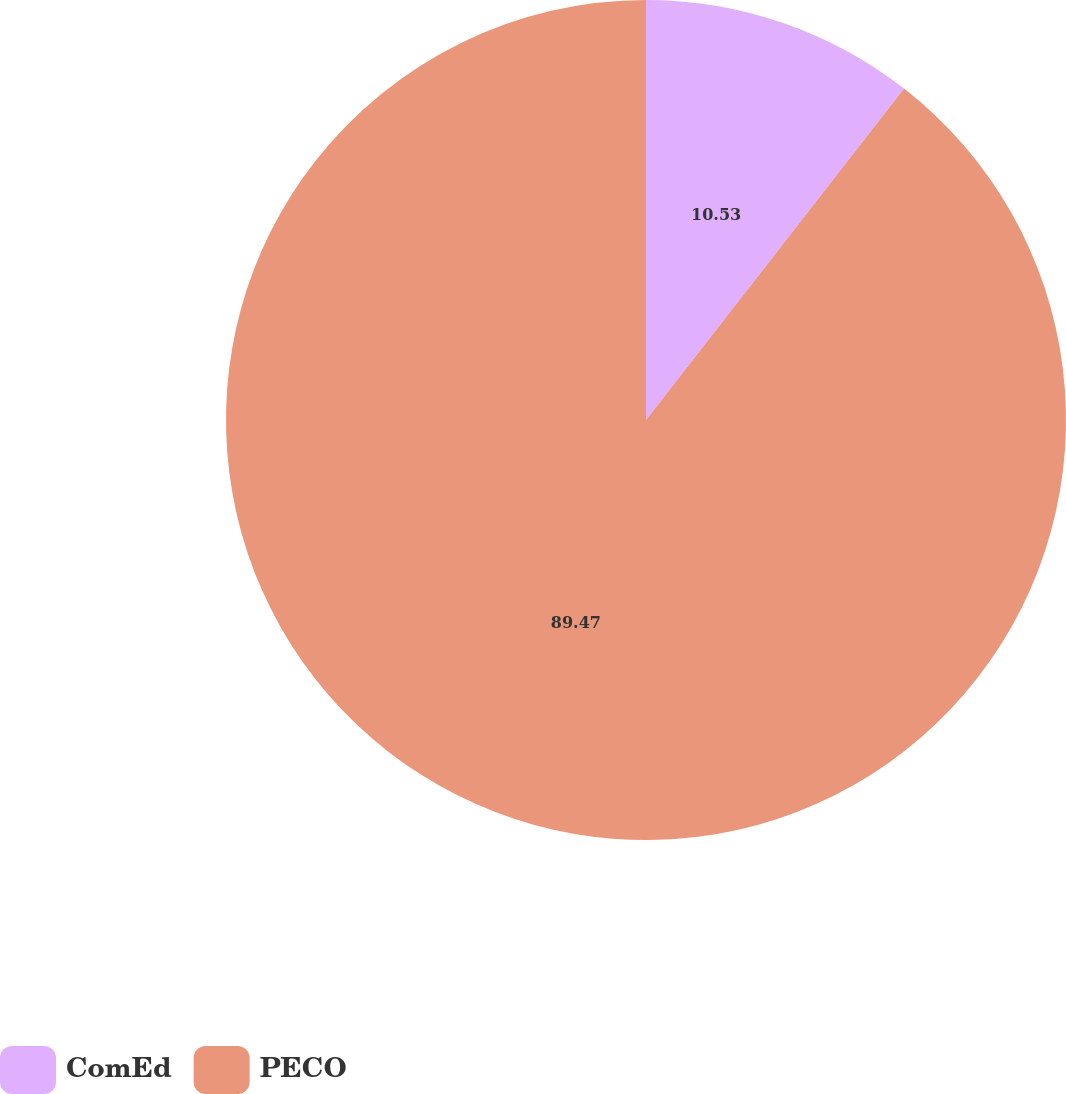Convert chart to OTSL. <chart><loc_0><loc_0><loc_500><loc_500><pie_chart><fcel>ComEd<fcel>PECO<nl><fcel>10.53%<fcel>89.47%<nl></chart> 